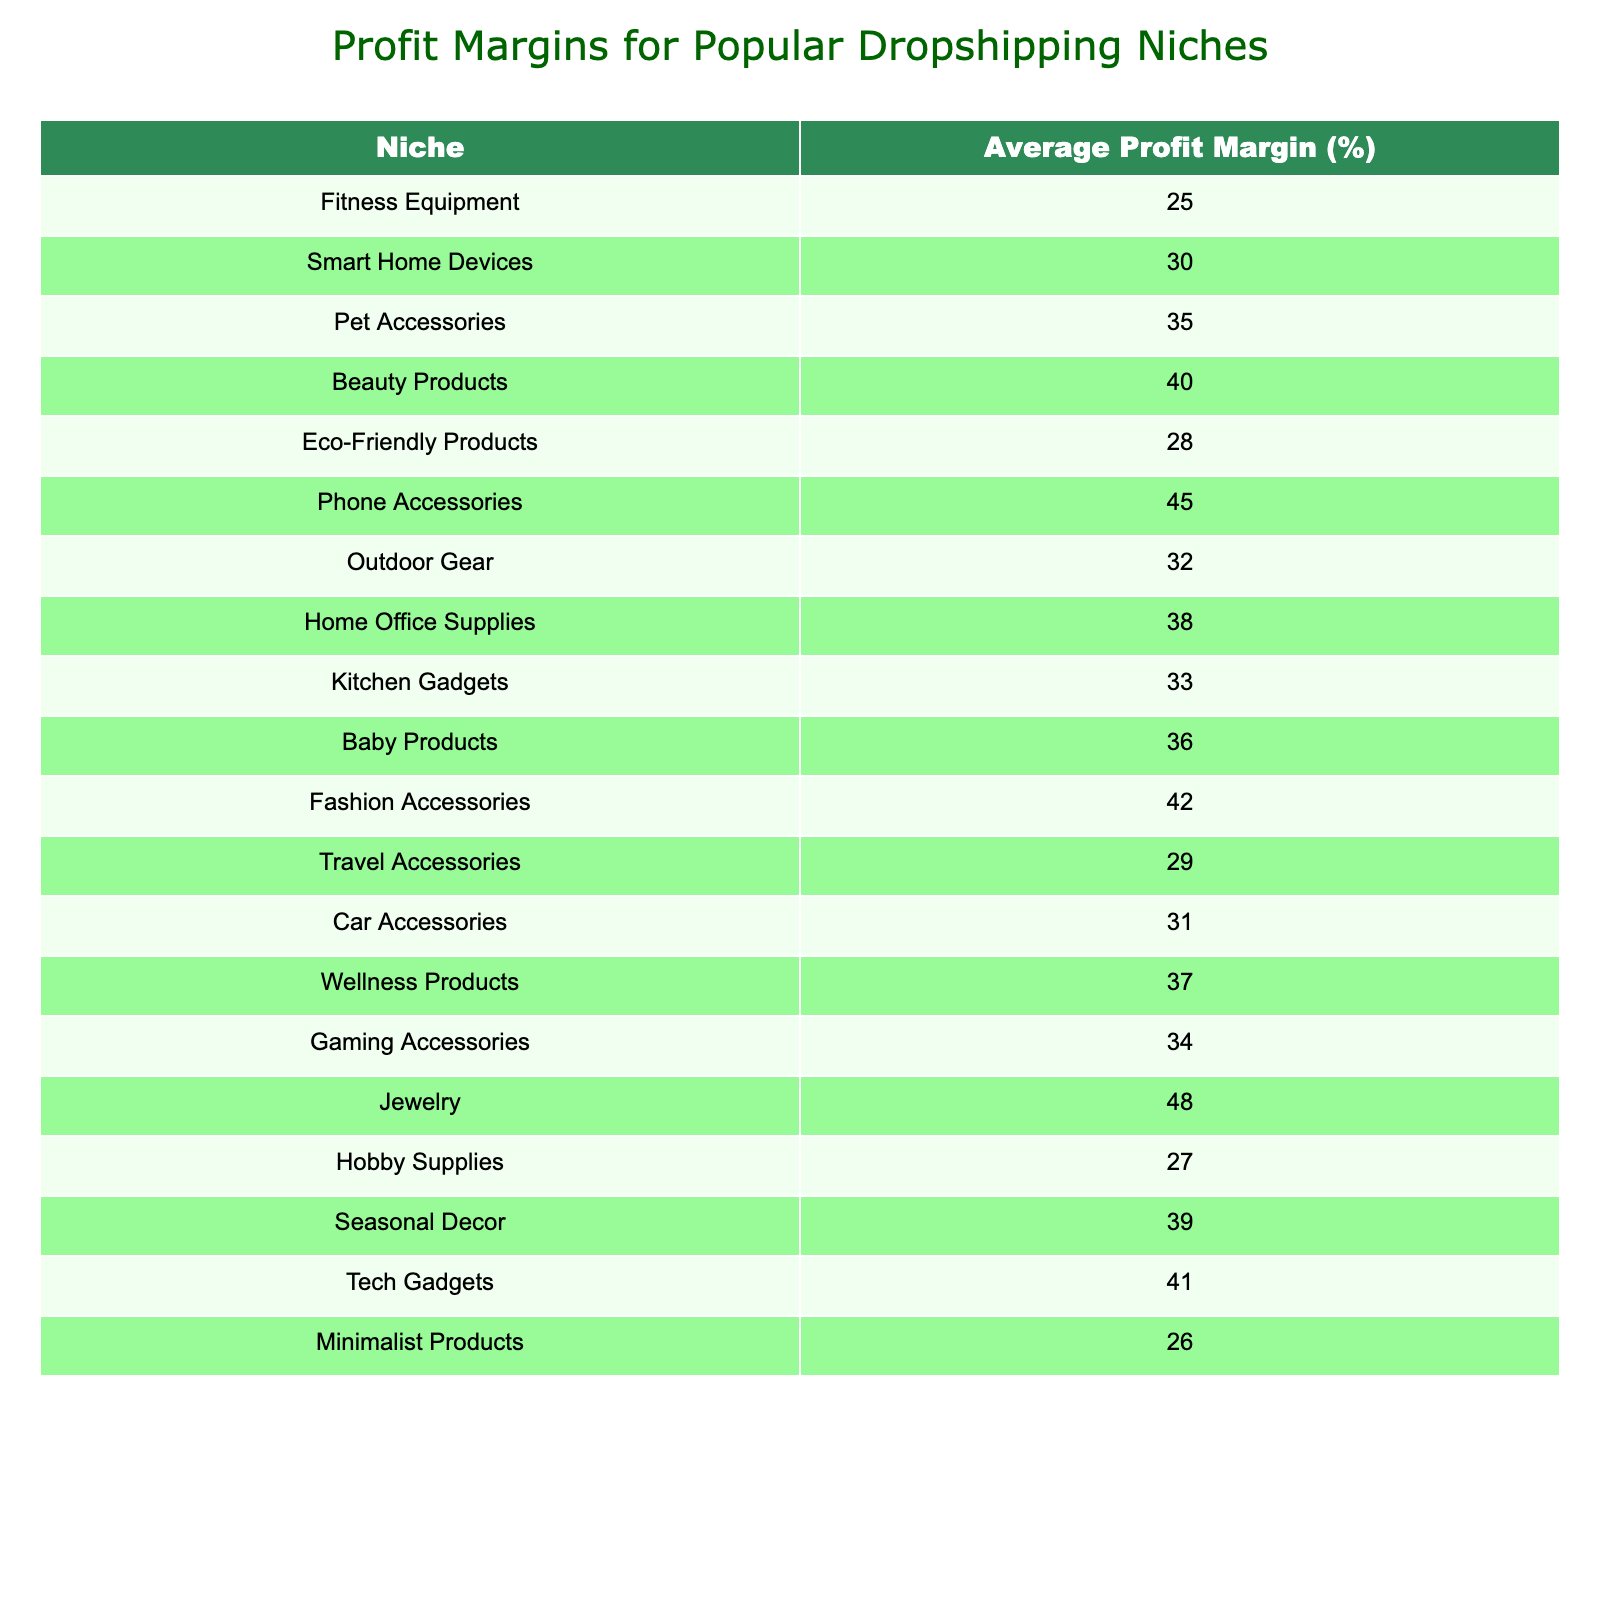What is the average profit margin for Fashion Accessories? The table lists the average profit margin for Fashion Accessories as 42%.
Answer: 42% Which niche has the highest profit margin? Looking through the table, Jewelry has the highest profit margin listed at 48%.
Answer: 48% What is the profit margin difference between Pet Accessories and Eco-Friendly Products? The profit margin for Pet Accessories is 35% and for Eco-Friendly Products it is 28%. The difference is 35% - 28% = 7%.
Answer: 7% Is the profit margin for Smart Home Devices greater than 30%? The table shows the profit margin for Smart Home Devices is 30%, which means it is not greater than 30%.
Answer: No Calculate the average profit margin for Outdoor Gear, Home Office Supplies, and Kitchen Gadgets. The profit margins for those niches are 32%, 38%, and 33% respectively. To find the average, we add them together (32 + 38 + 33 = 103) and divide by 3, resulting in 103 / 3 = 34.33%.
Answer: 34.33% Which niches have a profit margin greater than 40%? By reviewing the table, we see that the niches with profit margins over 40% are Beauty Products (40%), Phone Accessories (45%), Fashion Accessories (42%), Jewelry (48%), and Tech Gadgets (41%).
Answer: Beauty Products, Phone Accessories, Fashion Accessories, Jewelry, Tech Gadgets What is the total profit margin for the top three niches by profit margin? The top three niches by profit margin are Jewelry (48%), Phone Accessories (45%), and Fashion Accessories (42%). The total is 48 + 45 + 42 = 135%.
Answer: 135% Are there more niches with profit margins above or below 30%? The table lists 14 niches in total. Counting those above 30%, we see 8: Smart Home Devices, Pet Accessories, Beauty Products, Phone Accessories, Outdoor Gear, Home Office Supplies, Wellness Products, Gaming Accessories, Jewelry, and Tech Gadgets. Below 30% are 6: Fitness Equipment, Eco-Friendly Products, Fashion Accessories, Travel Accessories, Car Accessories, and Hobby Supplies. There are more above 30%.
Answer: Above 30% What is the median profit margin in this table? First, list all the profit margins in order: 25, 26, 27, 28, 29, 30, 31, 32, 33, 34, 35, 36, 37, 38, 39, 40, 41, 42, 45, 48. There are 20 data points, so the median is the average of the 10th and 11th values (34 and 35), resulting in (34 + 35)/2 = 34.5%.
Answer: 34.5% 